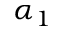Convert formula to latex. <formula><loc_0><loc_0><loc_500><loc_500>\alpha _ { 1 }</formula> 